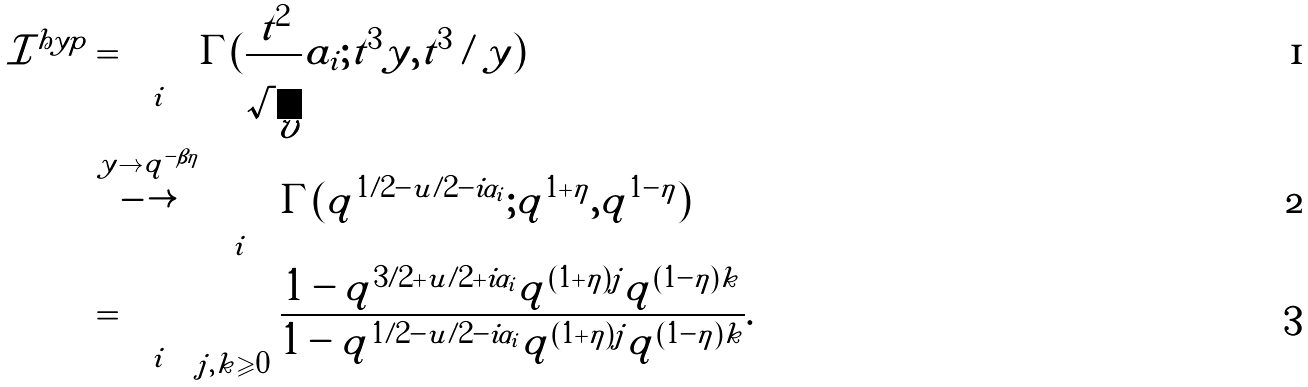<formula> <loc_0><loc_0><loc_500><loc_500>\mathcal { I } ^ { h y p } & = \prod _ { i } \Gamma ( \frac { t ^ { 2 } } { \sqrt { v } } a _ { i } ; t ^ { 3 } y , t ^ { 3 } / y ) \\ & \stackrel { y \to q ^ { - \beta \eta } } { \longrightarrow } \prod _ { i } \Gamma ( q ^ { 1 / 2 - u / 2 - i \alpha _ { i } } ; q ^ { 1 + \eta } , q ^ { 1 - \eta } ) \\ & = \prod _ { i } \prod _ { j , k \geqslant 0 } \frac { 1 - q ^ { 3 / 2 + u / 2 + i \alpha _ { i } } q ^ { ( 1 + \eta ) j } q ^ { ( 1 - \eta ) k } } { 1 - q ^ { 1 / 2 - u / 2 - i \alpha _ { i } } q ^ { ( 1 + \eta ) j } q ^ { ( 1 - \eta ) k } } .</formula> 